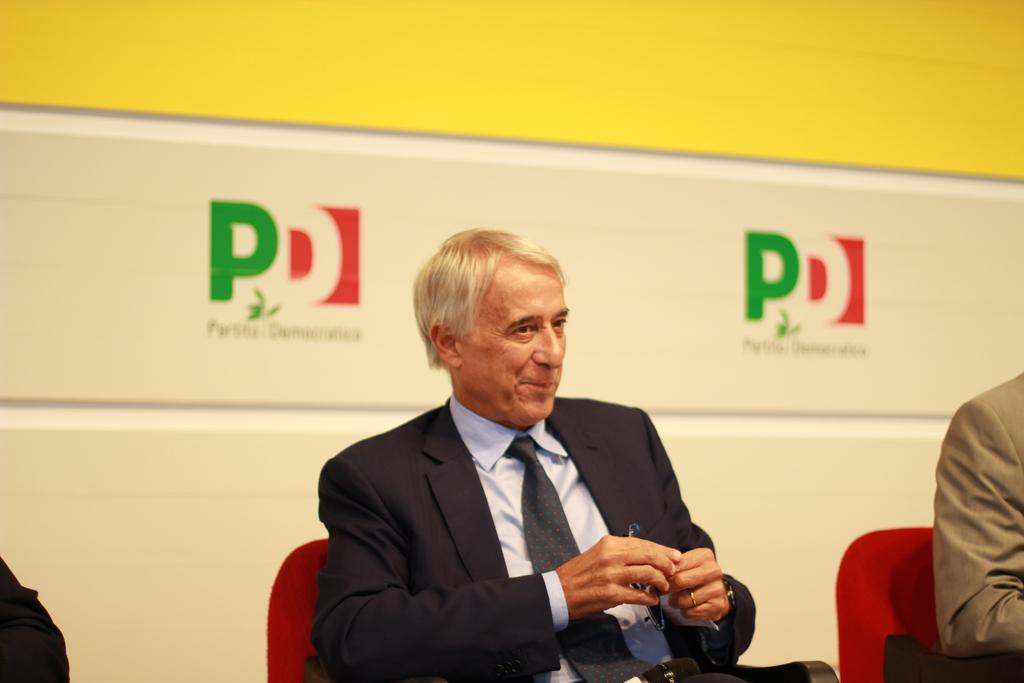What are the people in the image doing? The people in the image are sitting on chairs. What can be seen in the background of the image? There is a wall visible in the background of the image. What is written on the wall in the background? There is text written on the wall in the background. What date is circled on the calendar in the image? There is no calendar present in the image, so it is not possible to answer that question. 